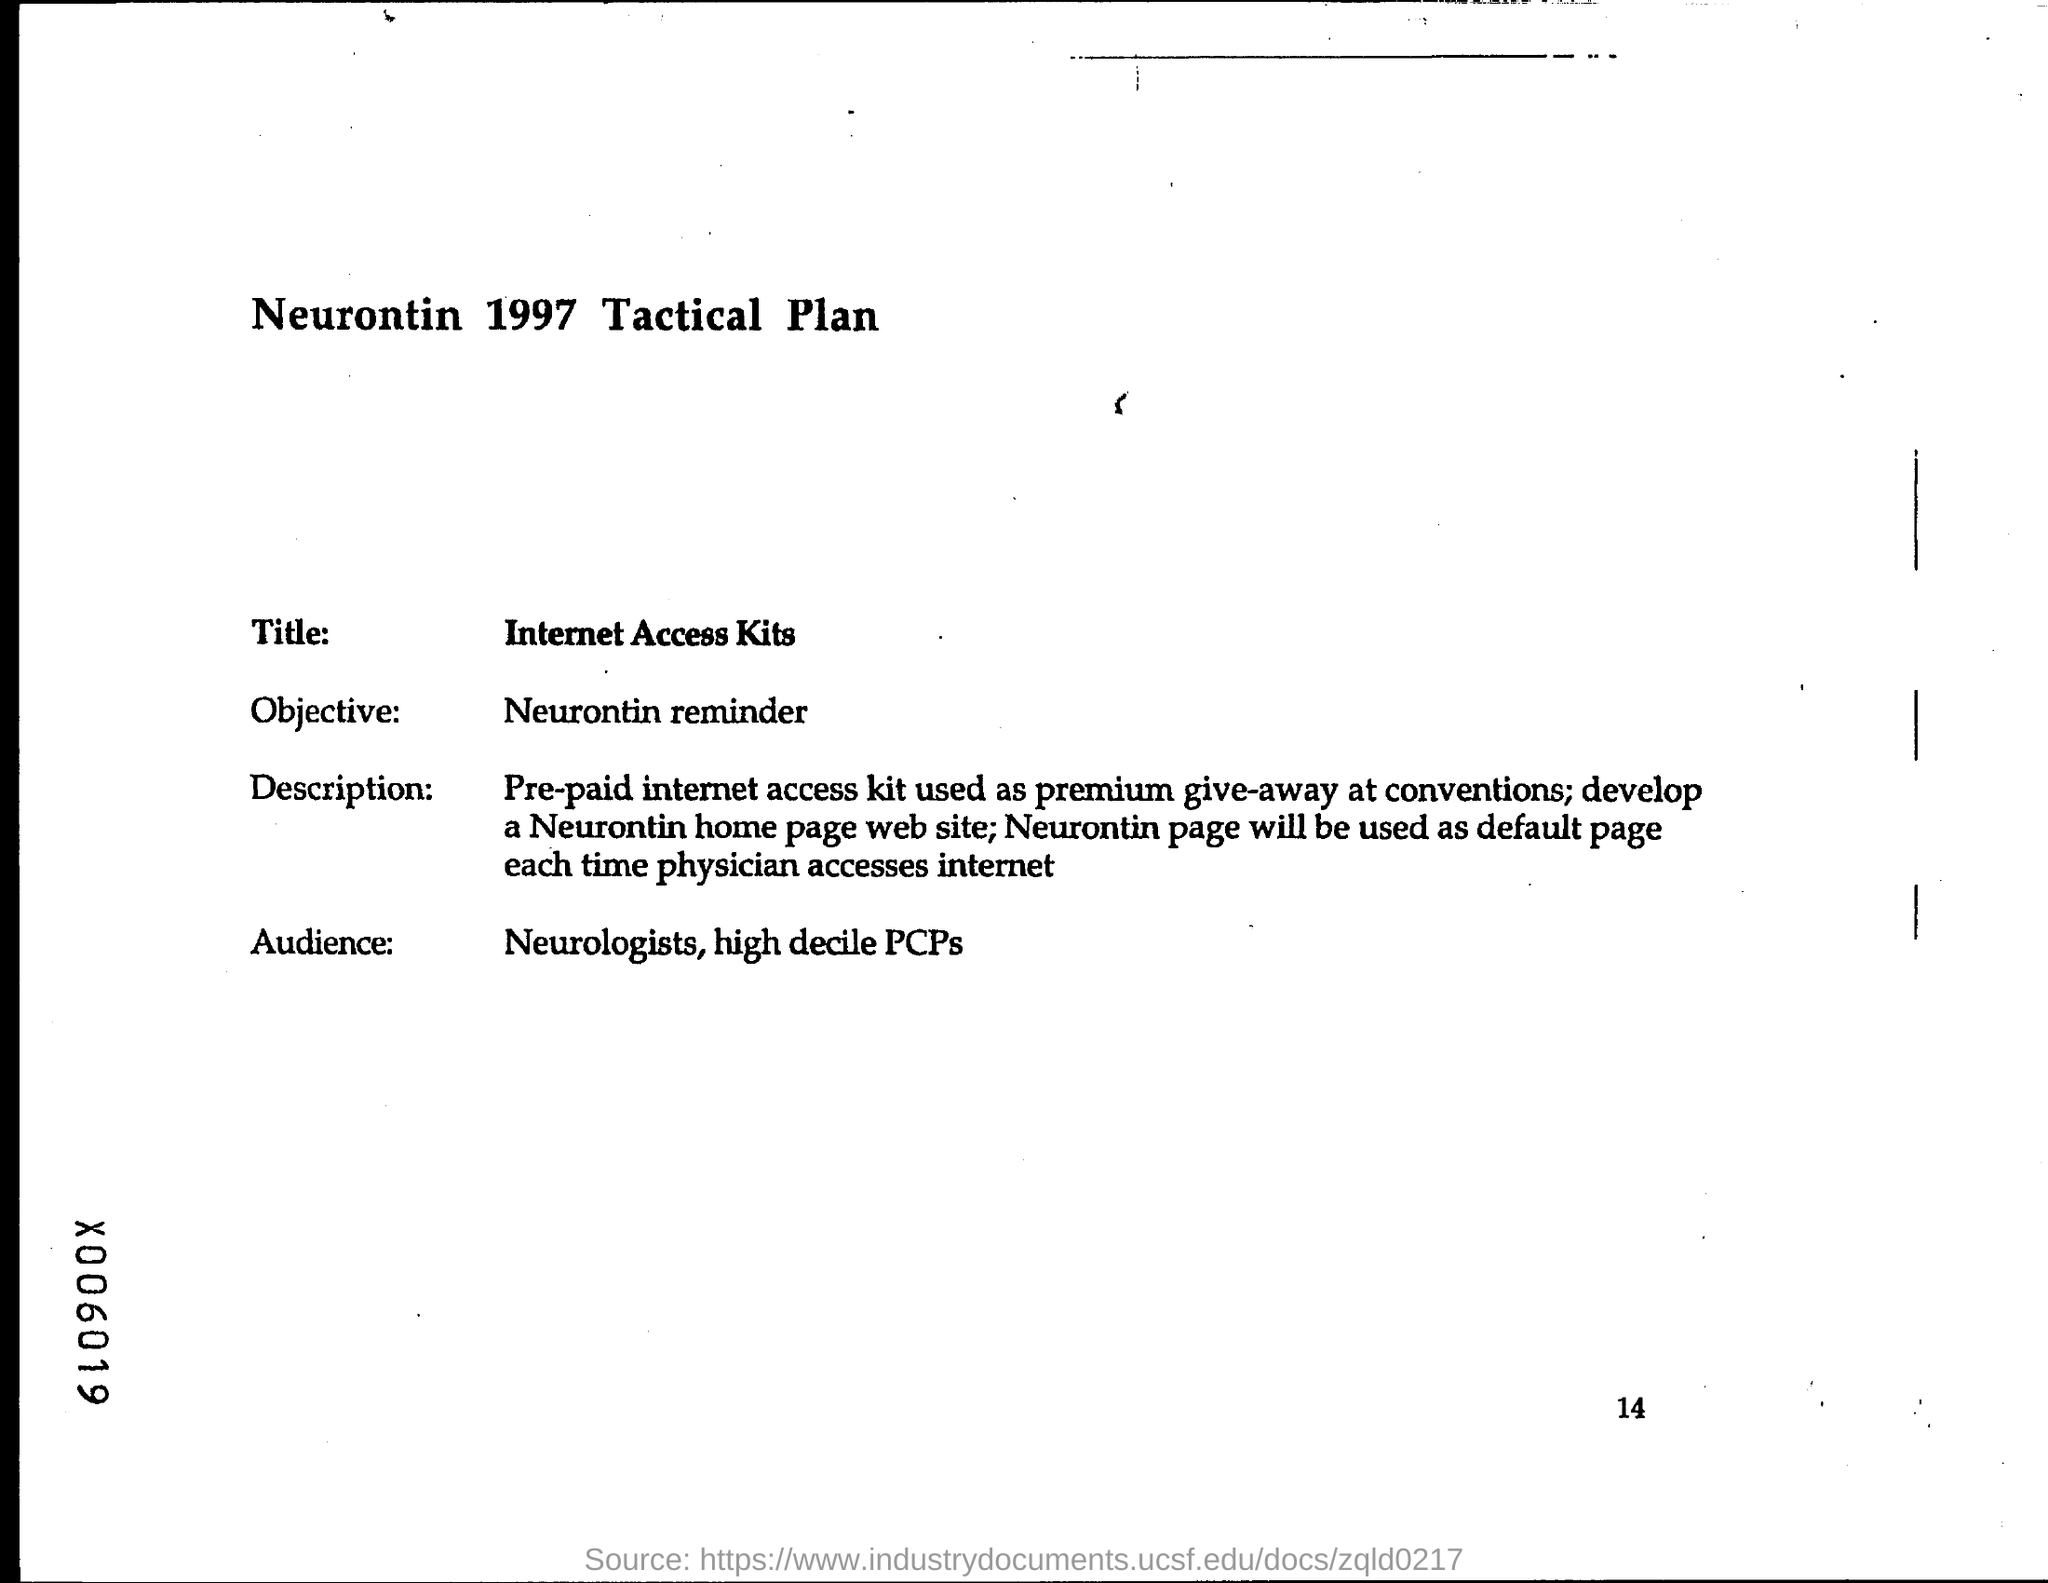What is the Title?
Your response must be concise. Internet Access Kits. What is the Objective?
Give a very brief answer. Neurontin reminder. Who are the Audience?
Ensure brevity in your answer.  Neurologists, high decile PCPs. 